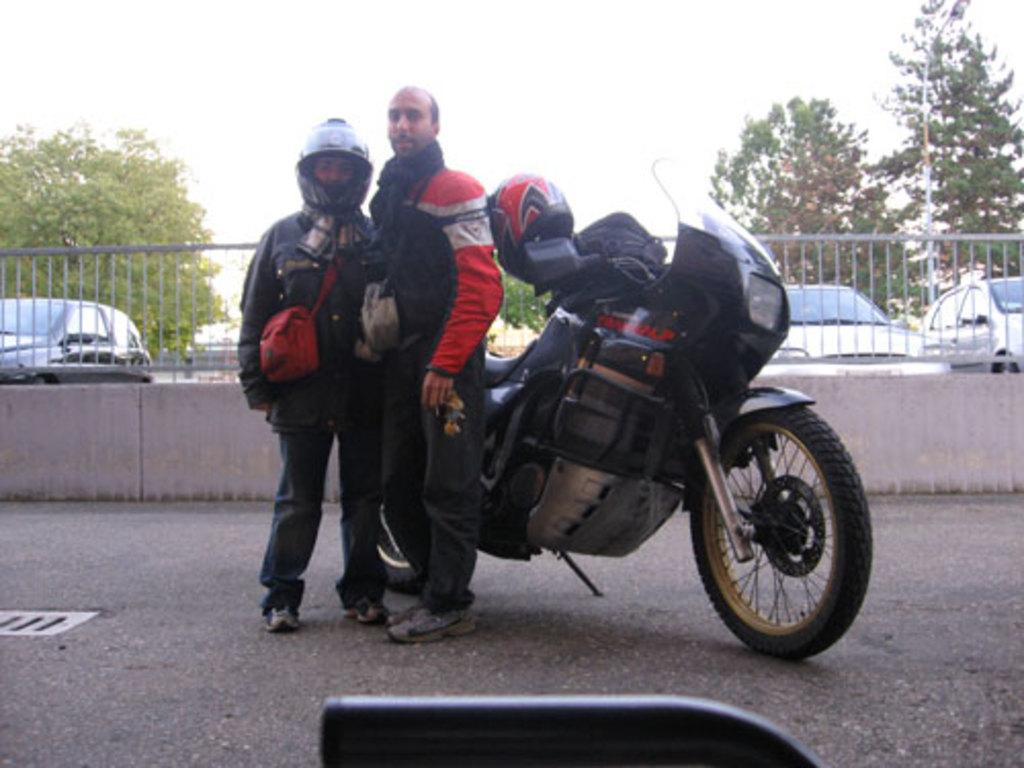How many people are present in the image? There are people in the image, but the exact number is not specified. What types of vehicles can be seen in the image? There are vehicles in the image, but the specific types are not mentioned. What is the purpose of the railing in the image? The purpose of the railing is not clear from the provided facts. What kind of vegetation is visible in the image? There are trees in the image. What is visible in the sky in the image? The sky is visible in the image. What protective gear is one person wearing in the image? One person is wearing a helmet in the image. What accessory are two people wearing in the image? Two people are wearing bags in the image. What safety item is present on the bike in the image? There is a helmet on the bike in the image. How many cats are sitting on the linen in the image? There are no cats or linen present in the image. What type of mask is being worn by the person in the image? There is no mention of a mask in the image. 